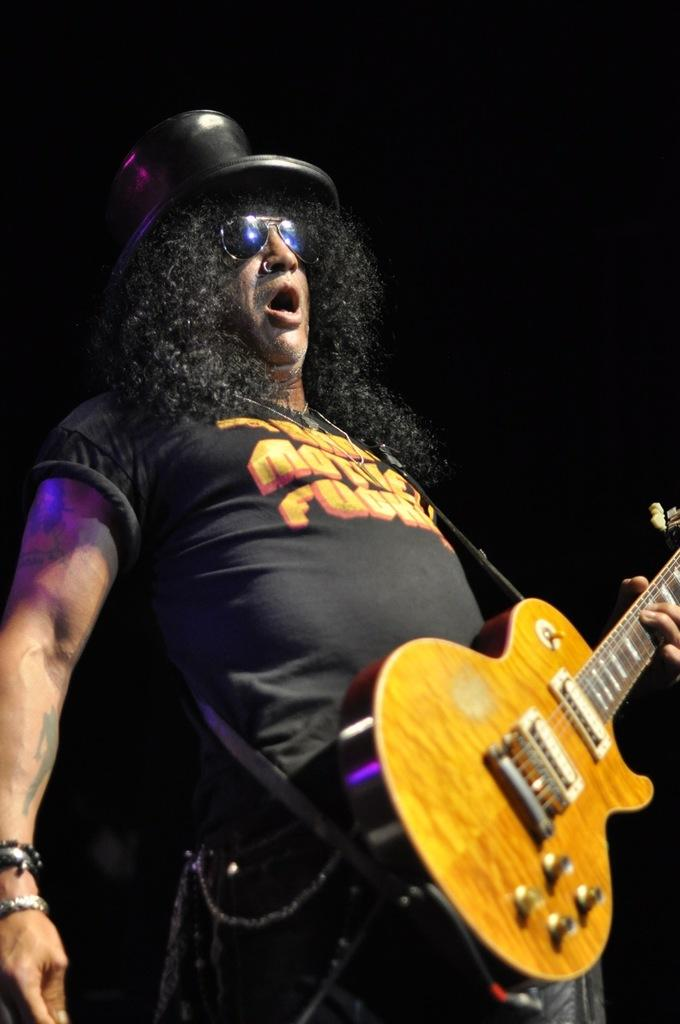What is the main subject of the image? There is a person in the image. What is the person holding in the image? The person is holding a guitar. What type of jewel can be seen on the person's neck in the image? There is no jewel visible on the person's neck in the image. What kind of rat is sitting next to the person in the image? There is no rat present in the image. 